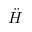Convert formula to latex. <formula><loc_0><loc_0><loc_500><loc_500>\ddot { H }</formula> 